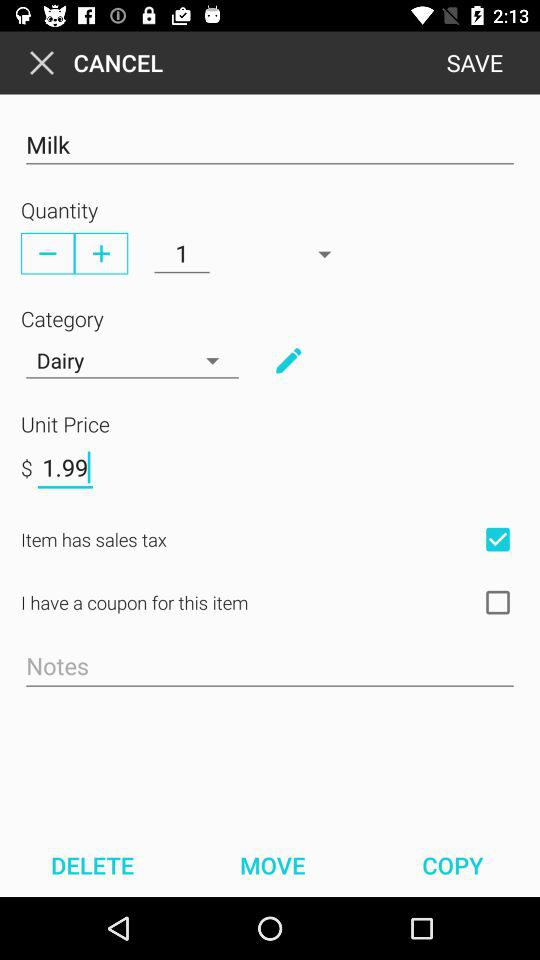What is the price of the product? The price is $1.99. 